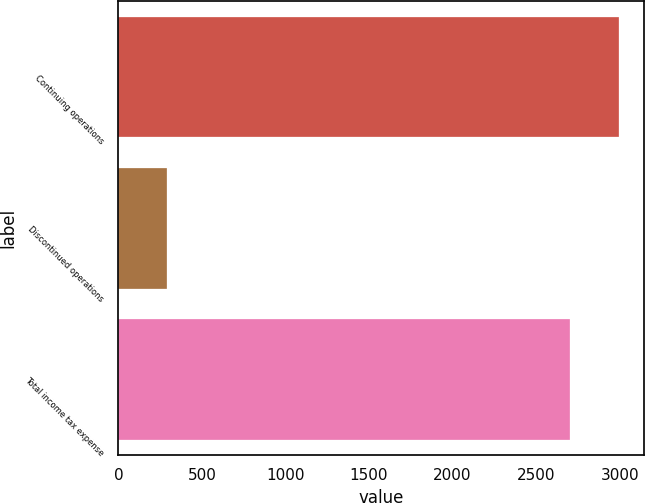Convert chart. <chart><loc_0><loc_0><loc_500><loc_500><bar_chart><fcel>Continuing operations<fcel>Discontinued operations<fcel>Total income tax expense<nl><fcel>2994<fcel>289<fcel>2705<nl></chart> 